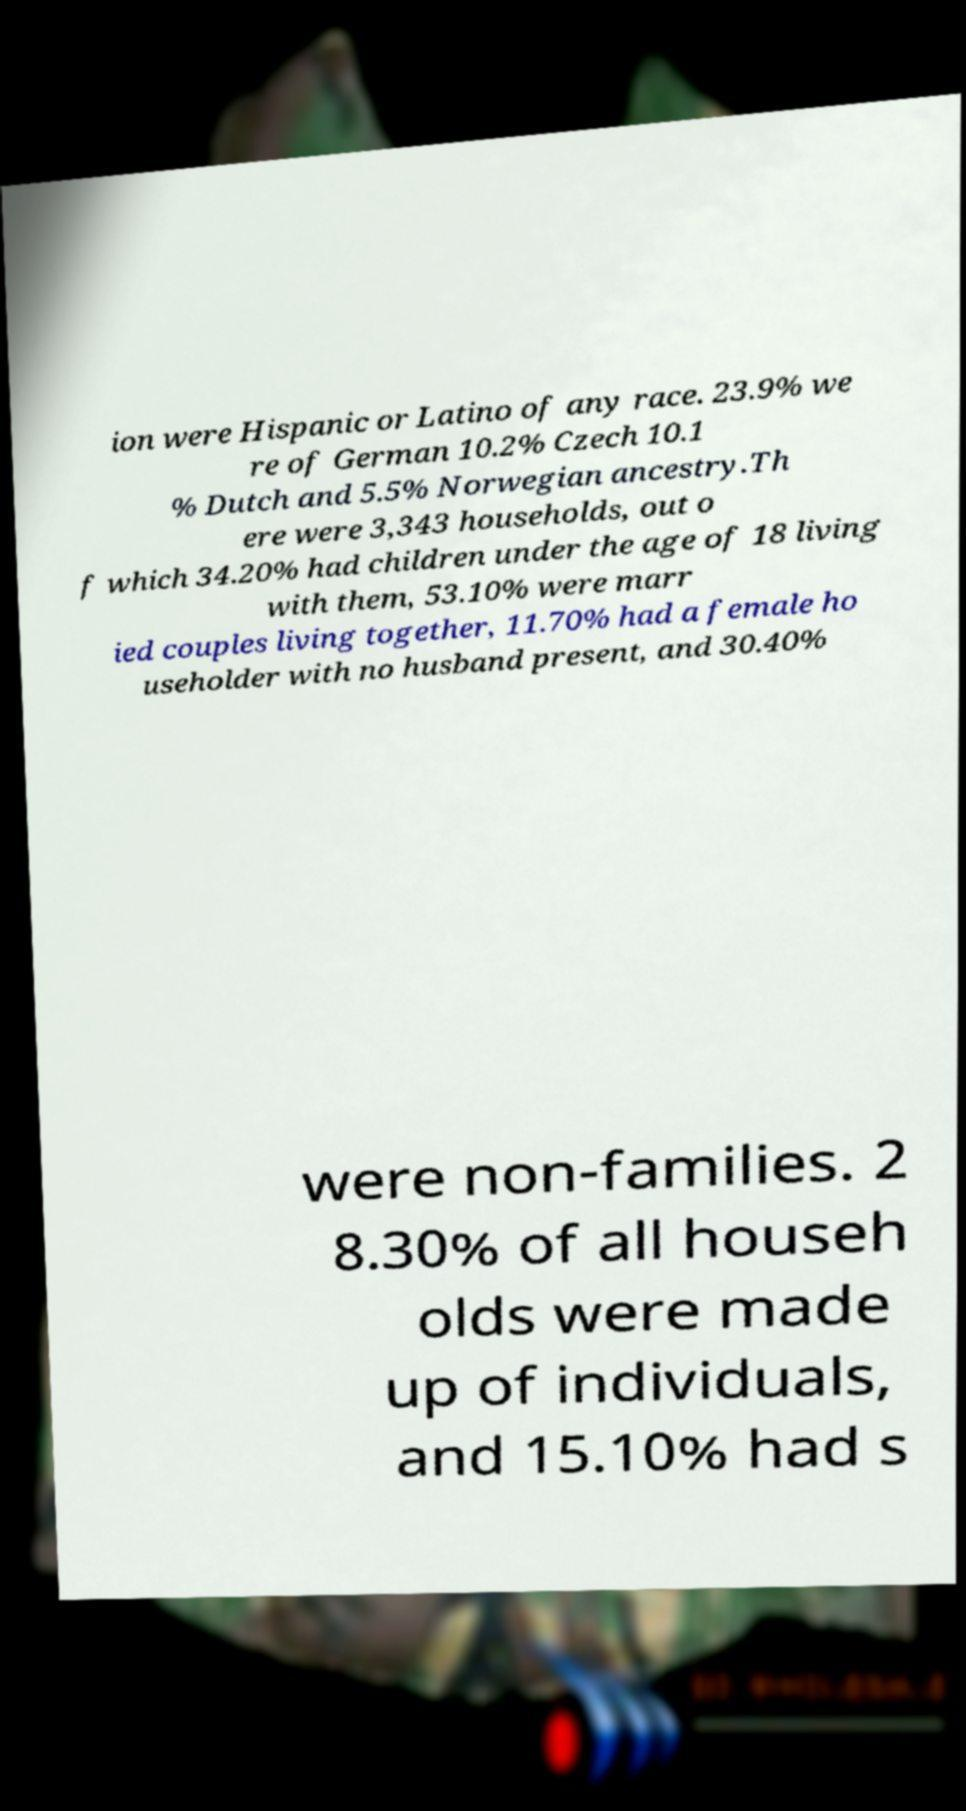Please identify and transcribe the text found in this image. ion were Hispanic or Latino of any race. 23.9% we re of German 10.2% Czech 10.1 % Dutch and 5.5% Norwegian ancestry.Th ere were 3,343 households, out o f which 34.20% had children under the age of 18 living with them, 53.10% were marr ied couples living together, 11.70% had a female ho useholder with no husband present, and 30.40% were non-families. 2 8.30% of all househ olds were made up of individuals, and 15.10% had s 